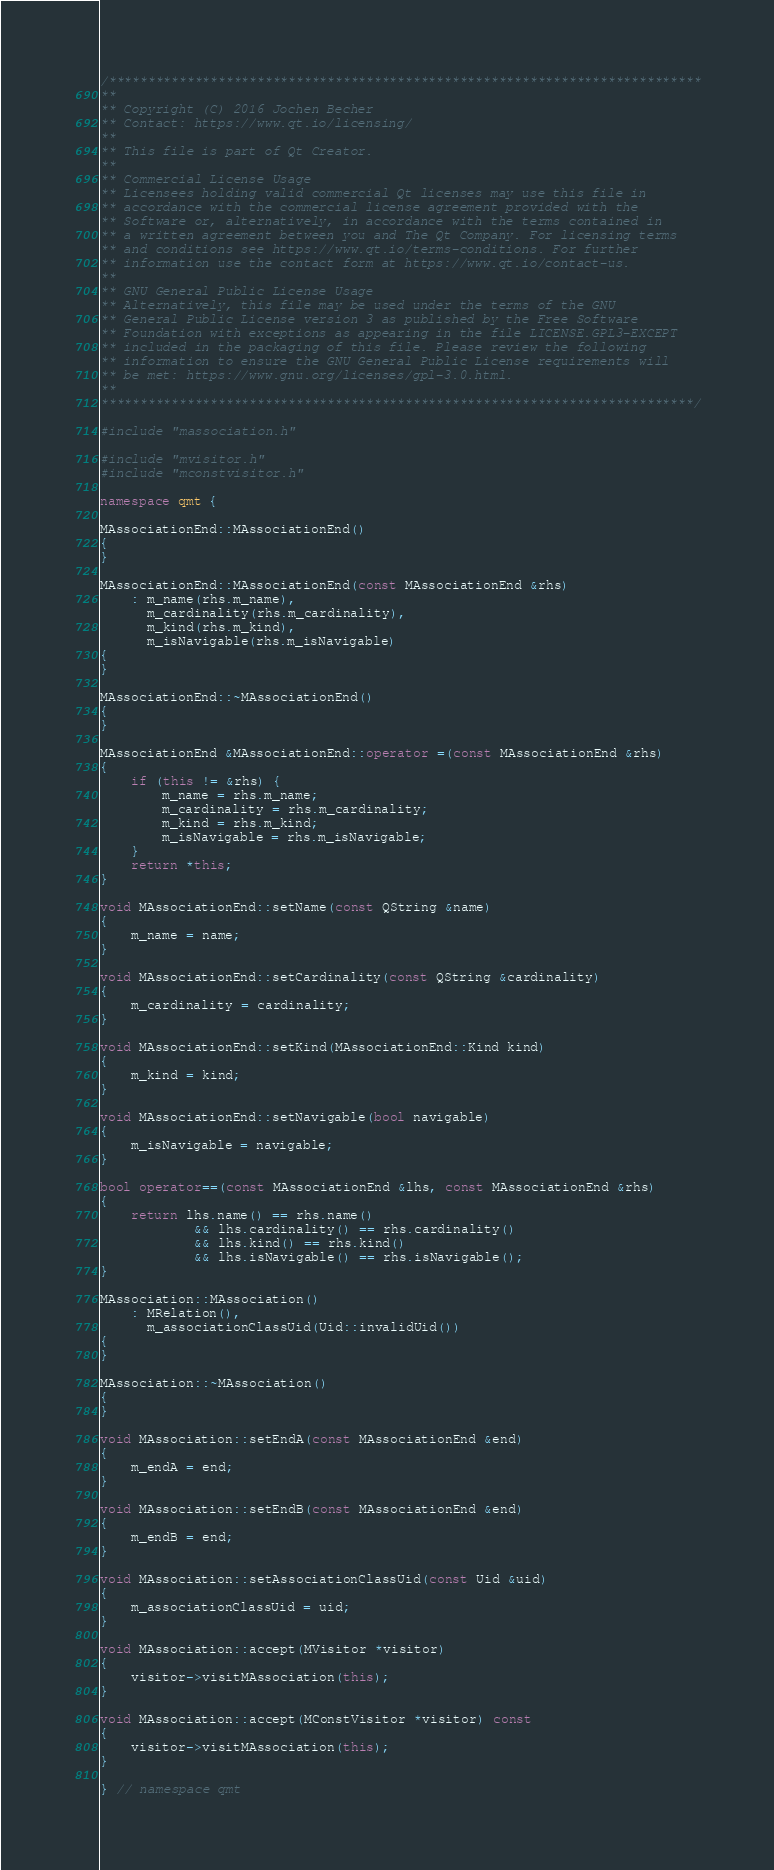Convert code to text. <code><loc_0><loc_0><loc_500><loc_500><_C++_>/****************************************************************************
**
** Copyright (C) 2016 Jochen Becher
** Contact: https://www.qt.io/licensing/
**
** This file is part of Qt Creator.
**
** Commercial License Usage
** Licensees holding valid commercial Qt licenses may use this file in
** accordance with the commercial license agreement provided with the
** Software or, alternatively, in accordance with the terms contained in
** a written agreement between you and The Qt Company. For licensing terms
** and conditions see https://www.qt.io/terms-conditions. For further
** information use the contact form at https://www.qt.io/contact-us.
**
** GNU General Public License Usage
** Alternatively, this file may be used under the terms of the GNU
** General Public License version 3 as published by the Free Software
** Foundation with exceptions as appearing in the file LICENSE.GPL3-EXCEPT
** included in the packaging of this file. Please review the following
** information to ensure the GNU General Public License requirements will
** be met: https://www.gnu.org/licenses/gpl-3.0.html.
**
****************************************************************************/

#include "massociation.h"

#include "mvisitor.h"
#include "mconstvisitor.h"

namespace qmt {

MAssociationEnd::MAssociationEnd()
{
}

MAssociationEnd::MAssociationEnd(const MAssociationEnd &rhs)
    : m_name(rhs.m_name),
      m_cardinality(rhs.m_cardinality),
      m_kind(rhs.m_kind),
      m_isNavigable(rhs.m_isNavigable)
{
}

MAssociationEnd::~MAssociationEnd()
{
}

MAssociationEnd &MAssociationEnd::operator =(const MAssociationEnd &rhs)
{
    if (this != &rhs) {
        m_name = rhs.m_name;
        m_cardinality = rhs.m_cardinality;
        m_kind = rhs.m_kind;
        m_isNavigable = rhs.m_isNavigable;
    }
    return *this;
}

void MAssociationEnd::setName(const QString &name)
{
    m_name = name;
}

void MAssociationEnd::setCardinality(const QString &cardinality)
{
    m_cardinality = cardinality;
}

void MAssociationEnd::setKind(MAssociationEnd::Kind kind)
{
    m_kind = kind;
}

void MAssociationEnd::setNavigable(bool navigable)
{
    m_isNavigable = navigable;
}

bool operator==(const MAssociationEnd &lhs, const MAssociationEnd &rhs)
{
    return lhs.name() == rhs.name()
            && lhs.cardinality() == rhs.cardinality()
            && lhs.kind() == rhs.kind()
            && lhs.isNavigable() == rhs.isNavigable();
}

MAssociation::MAssociation()
    : MRelation(),
      m_associationClassUid(Uid::invalidUid())
{
}

MAssociation::~MAssociation()
{
}

void MAssociation::setEndA(const MAssociationEnd &end)
{
    m_endA = end;
}

void MAssociation::setEndB(const MAssociationEnd &end)
{
    m_endB = end;
}

void MAssociation::setAssociationClassUid(const Uid &uid)
{
    m_associationClassUid = uid;
}

void MAssociation::accept(MVisitor *visitor)
{
    visitor->visitMAssociation(this);
}

void MAssociation::accept(MConstVisitor *visitor) const
{
    visitor->visitMAssociation(this);
}

} // namespace qmt
</code> 